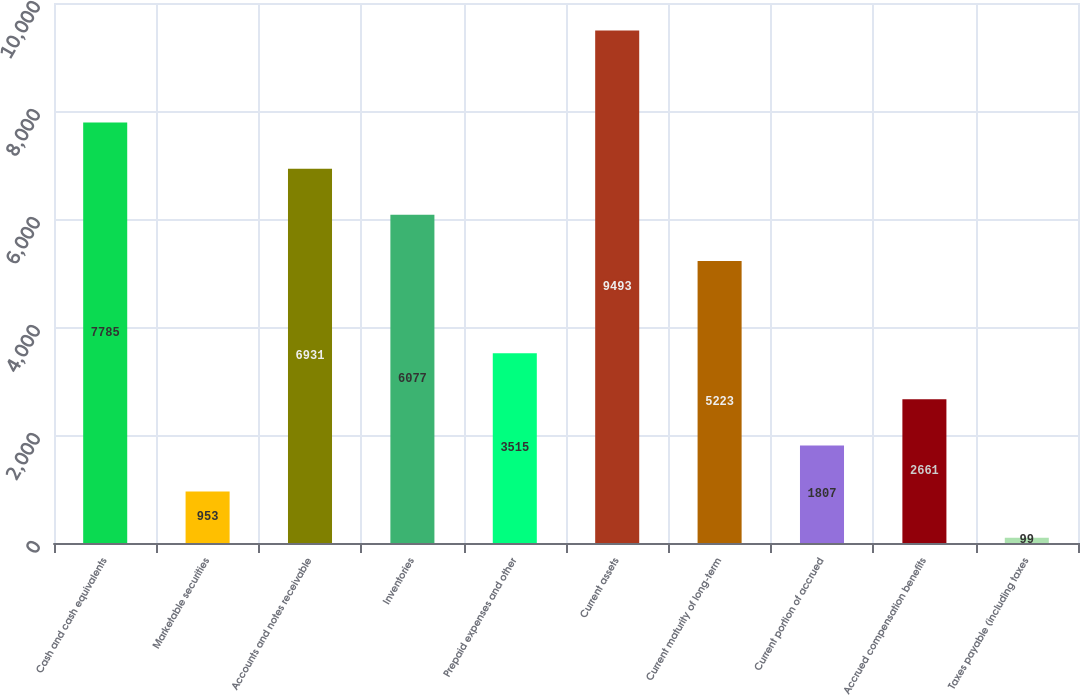<chart> <loc_0><loc_0><loc_500><loc_500><bar_chart><fcel>Cash and cash equivalents<fcel>Marketable securities<fcel>Accounts and notes receivable<fcel>Inventories<fcel>Prepaid expenses and other<fcel>Current assets<fcel>Current maturity of long-term<fcel>Current portion of accrued<fcel>Accrued compensation benefits<fcel>Taxes payable (including taxes<nl><fcel>7785<fcel>953<fcel>6931<fcel>6077<fcel>3515<fcel>9493<fcel>5223<fcel>1807<fcel>2661<fcel>99<nl></chart> 